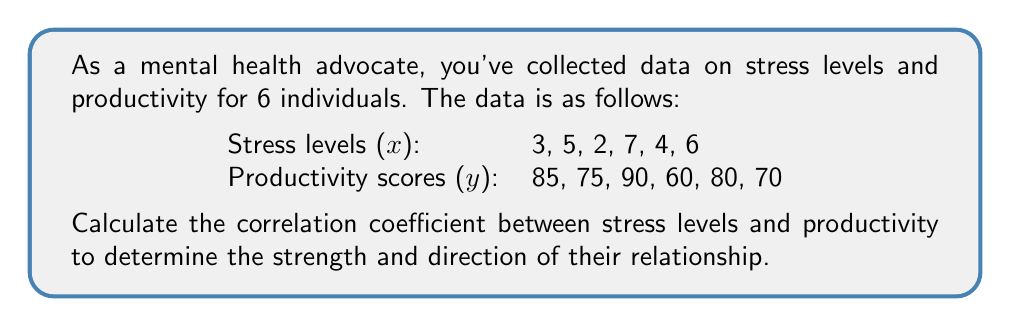Give your solution to this math problem. To calculate the correlation coefficient (r), we'll use the formula:

$$ r = \frac{n\sum xy - \sum x \sum y}{\sqrt{[n\sum x^2 - (\sum x)^2][n\sum y^2 - (\sum y)^2]}} $$

Where n is the number of data points.

Step 1: Calculate the required sums:
$n = 6$
$\sum x = 3 + 5 + 2 + 7 + 4 + 6 = 27$
$\sum y = 85 + 75 + 90 + 60 + 80 + 70 = 460$
$\sum xy = (3)(85) + (5)(75) + (2)(90) + (7)(60) + (4)(80) + (6)(70) = 2005$
$\sum x^2 = 3^2 + 5^2 + 2^2 + 7^2 + 4^2 + 6^2 = 139$
$\sum y^2 = 85^2 + 75^2 + 90^2 + 60^2 + 80^2 + 70^2 = 35850$

Step 2: Substitute these values into the formula:

$$ r = \frac{6(2005) - (27)(460)}{\sqrt{[6(139) - 27^2][6(35850) - 460^2]}} $$

Step 3: Simplify:

$$ r = \frac{12030 - 12420}{\sqrt{(834 - 729)(215100 - 211600)}} $$

$$ r = \frac{-390}{\sqrt{(105)(3500)}} $$

$$ r = \frac{-390}{\sqrt{367500}} $$

$$ r = \frac{-390}{606.22} $$

$$ r \approx -0.6433 $$
Answer: $-0.6433$ 